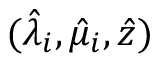Convert formula to latex. <formula><loc_0><loc_0><loc_500><loc_500>( \hat { \lambda } _ { i } , \hat { \mu } _ { i } , \hat { z } )</formula> 